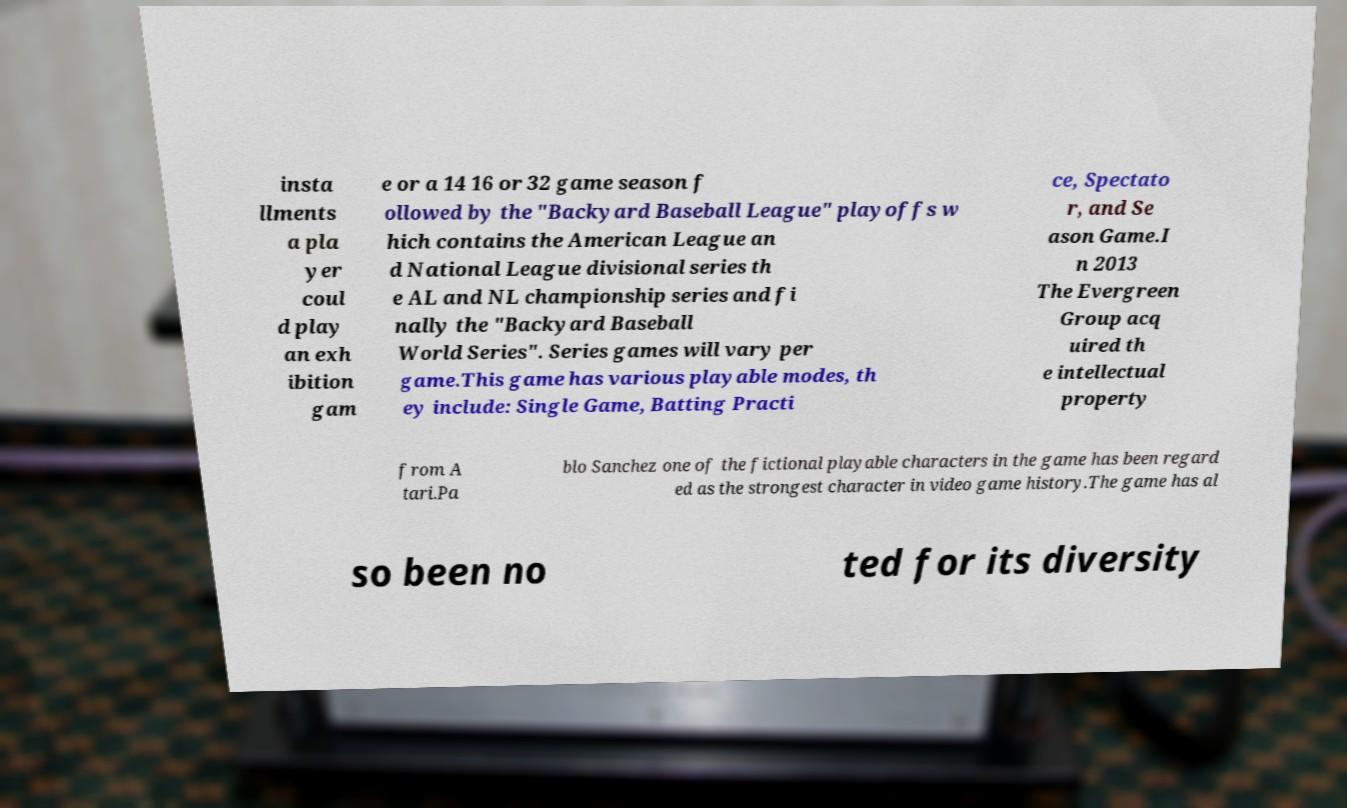Could you extract and type out the text from this image? insta llments a pla yer coul d play an exh ibition gam e or a 14 16 or 32 game season f ollowed by the "Backyard Baseball League" playoffs w hich contains the American League an d National League divisional series th e AL and NL championship series and fi nally the "Backyard Baseball World Series". Series games will vary per game.This game has various playable modes, th ey include: Single Game, Batting Practi ce, Spectato r, and Se ason Game.I n 2013 The Evergreen Group acq uired th e intellectual property from A tari.Pa blo Sanchez one of the fictional playable characters in the game has been regard ed as the strongest character in video game history.The game has al so been no ted for its diversity 